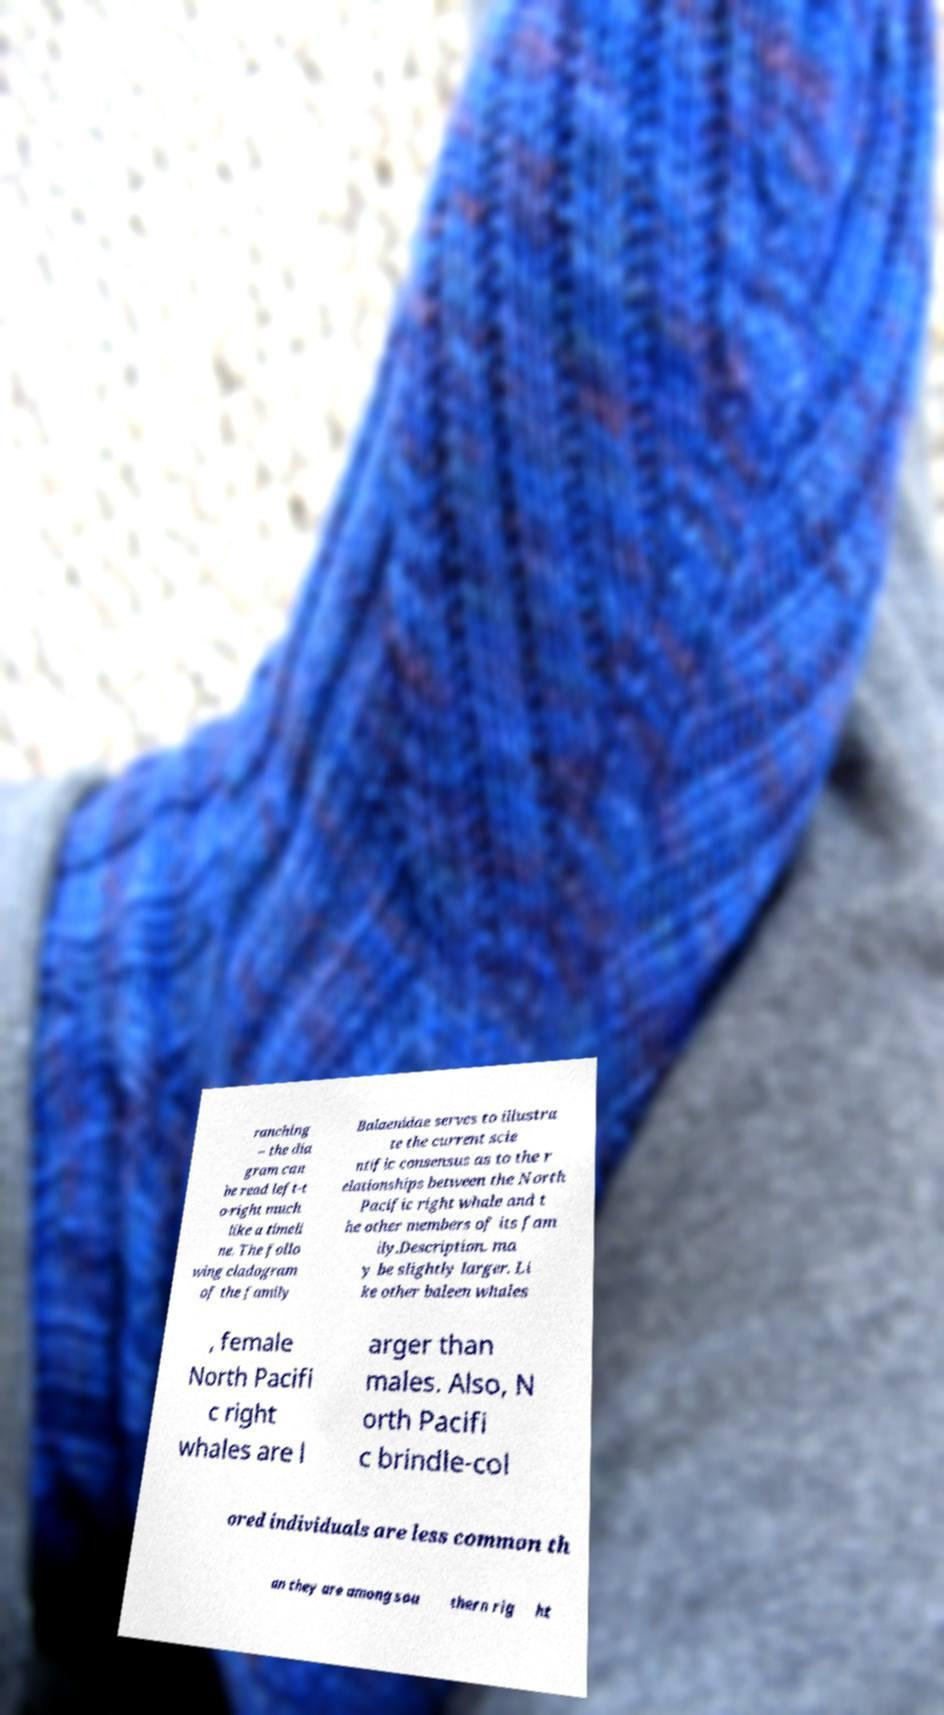Can you read and provide the text displayed in the image?This photo seems to have some interesting text. Can you extract and type it out for me? ranching – the dia gram can be read left-t o-right much like a timeli ne. The follo wing cladogram of the family Balaenidae serves to illustra te the current scie ntific consensus as to the r elationships between the North Pacific right whale and t he other members of its fam ily.Description. ma y be slightly larger. Li ke other baleen whales , female North Pacifi c right whales are l arger than males. Also, N orth Pacifi c brindle-col ored individuals are less common th an they are among sou thern rig ht 